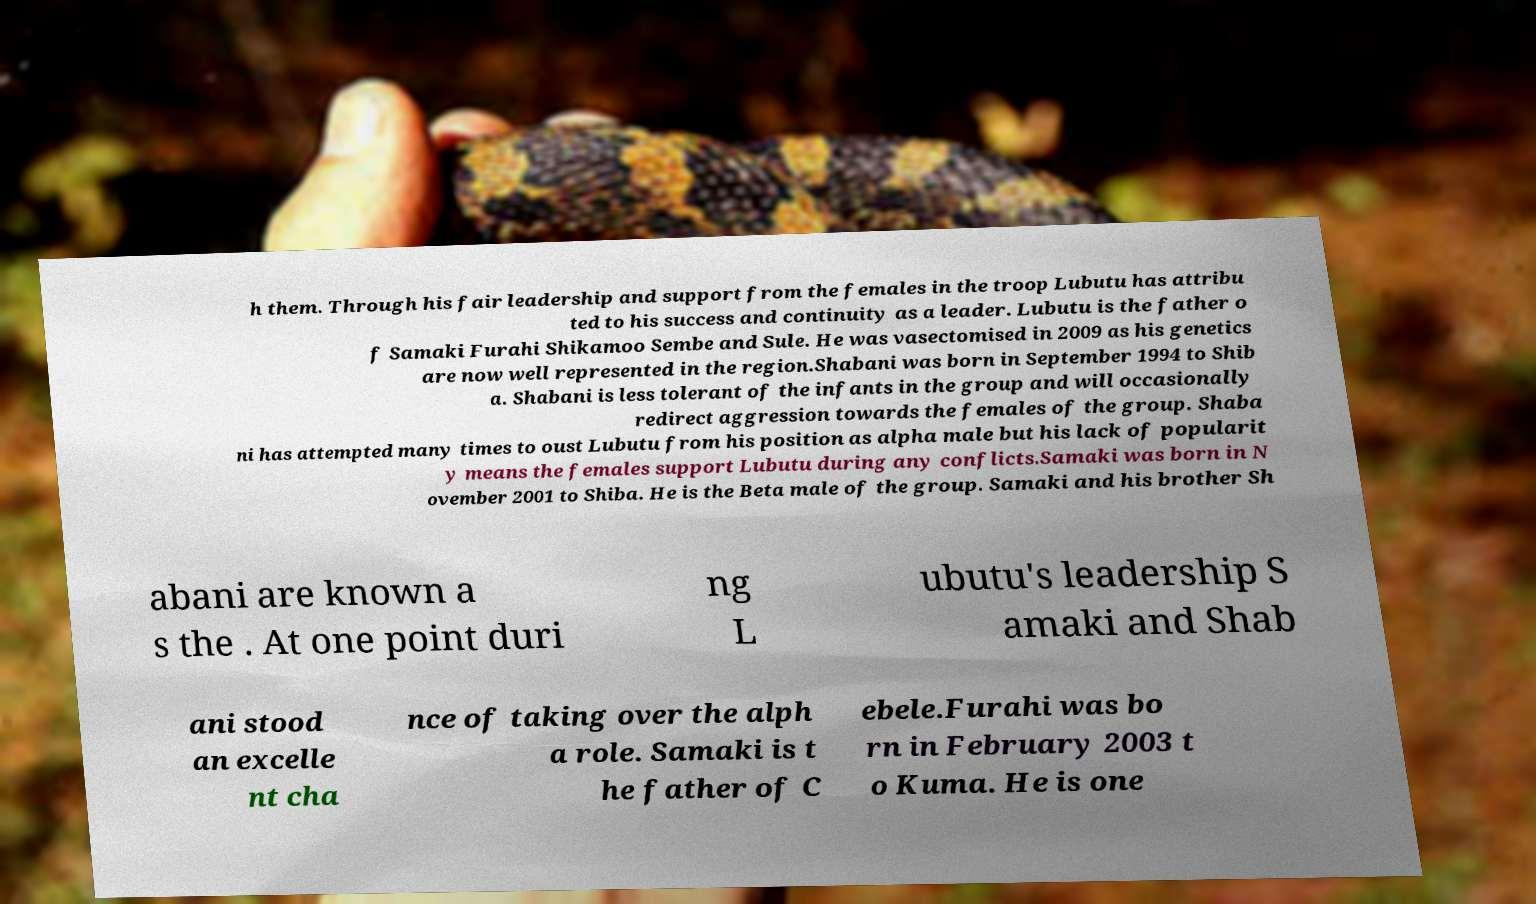Please read and relay the text visible in this image. What does it say? h them. Through his fair leadership and support from the females in the troop Lubutu has attribu ted to his success and continuity as a leader. Lubutu is the father o f Samaki Furahi Shikamoo Sembe and Sule. He was vasectomised in 2009 as his genetics are now well represented in the region.Shabani was born in September 1994 to Shib a. Shabani is less tolerant of the infants in the group and will occasionally redirect aggression towards the females of the group. Shaba ni has attempted many times to oust Lubutu from his position as alpha male but his lack of popularit y means the females support Lubutu during any conflicts.Samaki was born in N ovember 2001 to Shiba. He is the Beta male of the group. Samaki and his brother Sh abani are known a s the . At one point duri ng L ubutu's leadership S amaki and Shab ani stood an excelle nt cha nce of taking over the alph a role. Samaki is t he father of C ebele.Furahi was bo rn in February 2003 t o Kuma. He is one 